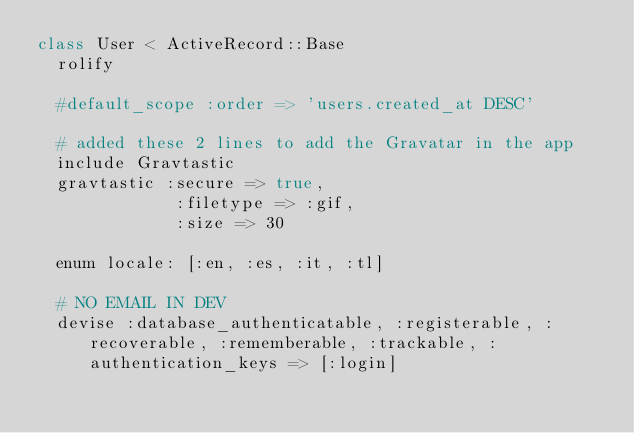<code> <loc_0><loc_0><loc_500><loc_500><_Ruby_>class User < ActiveRecord::Base
  rolify

  #default_scope :order => 'users.created_at DESC'

  # added these 2 lines to add the Gravatar in the app
  include Gravtastic
  gravtastic :secure => true,
              :filetype => :gif,
              :size => 30
  
  enum locale: [:en, :es, :it, :tl]

  # NO EMAIL IN DEV
  devise :database_authenticatable, :registerable, :recoverable, :rememberable, :trackable, :authentication_keys => [:login]
</code> 